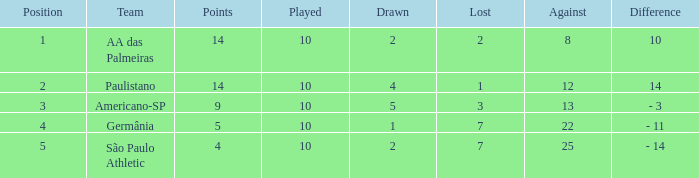What is the Against when the drawn is 5? 13.0. 